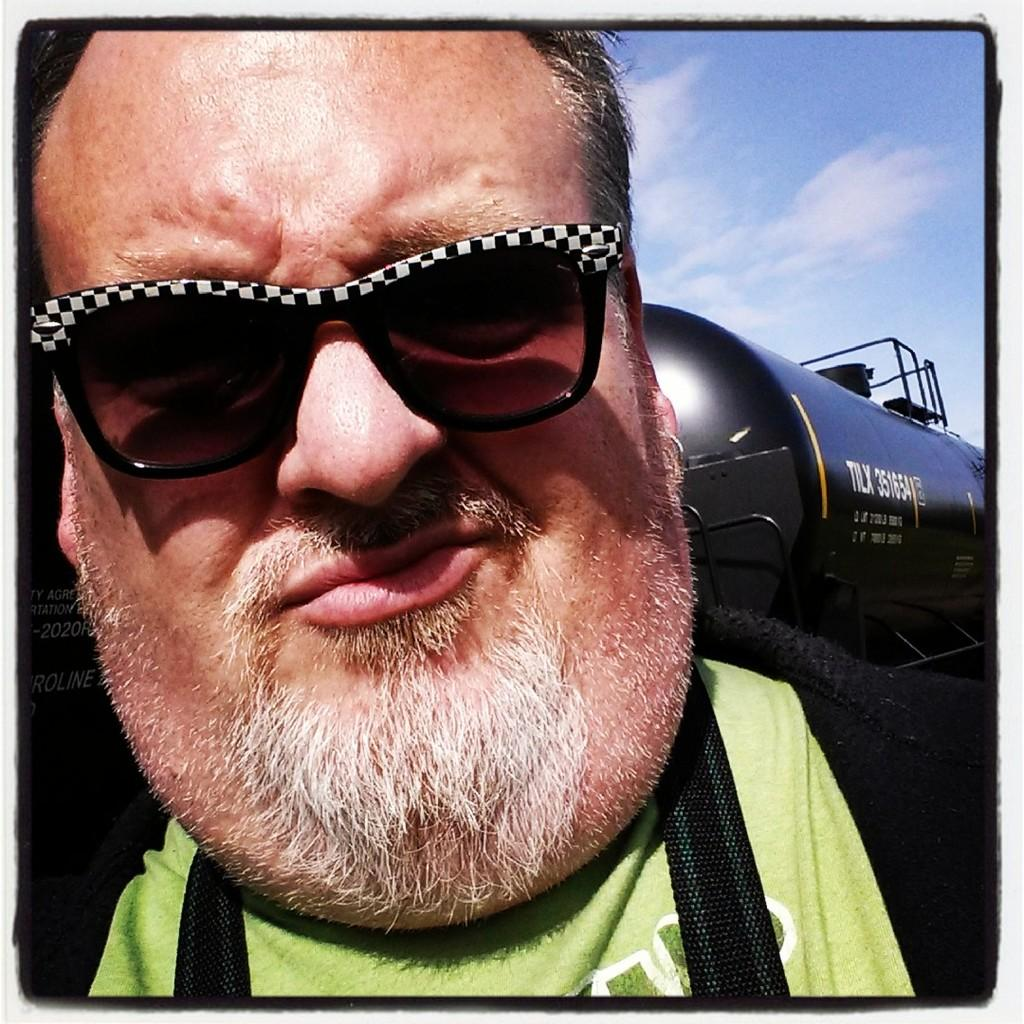What is the main subject of the image? There is a person in the image. What part of the person can be seen in the image? Only the person's face is visible in the image. What is the person wearing on their face? The person is wearing goggles. What can be seen in the background of the image? The sky is visible at the top of the image. What type of dress is the person wearing in the image? The image only shows the person's face, so it is not possible to determine what type of dress they might be wearing. 